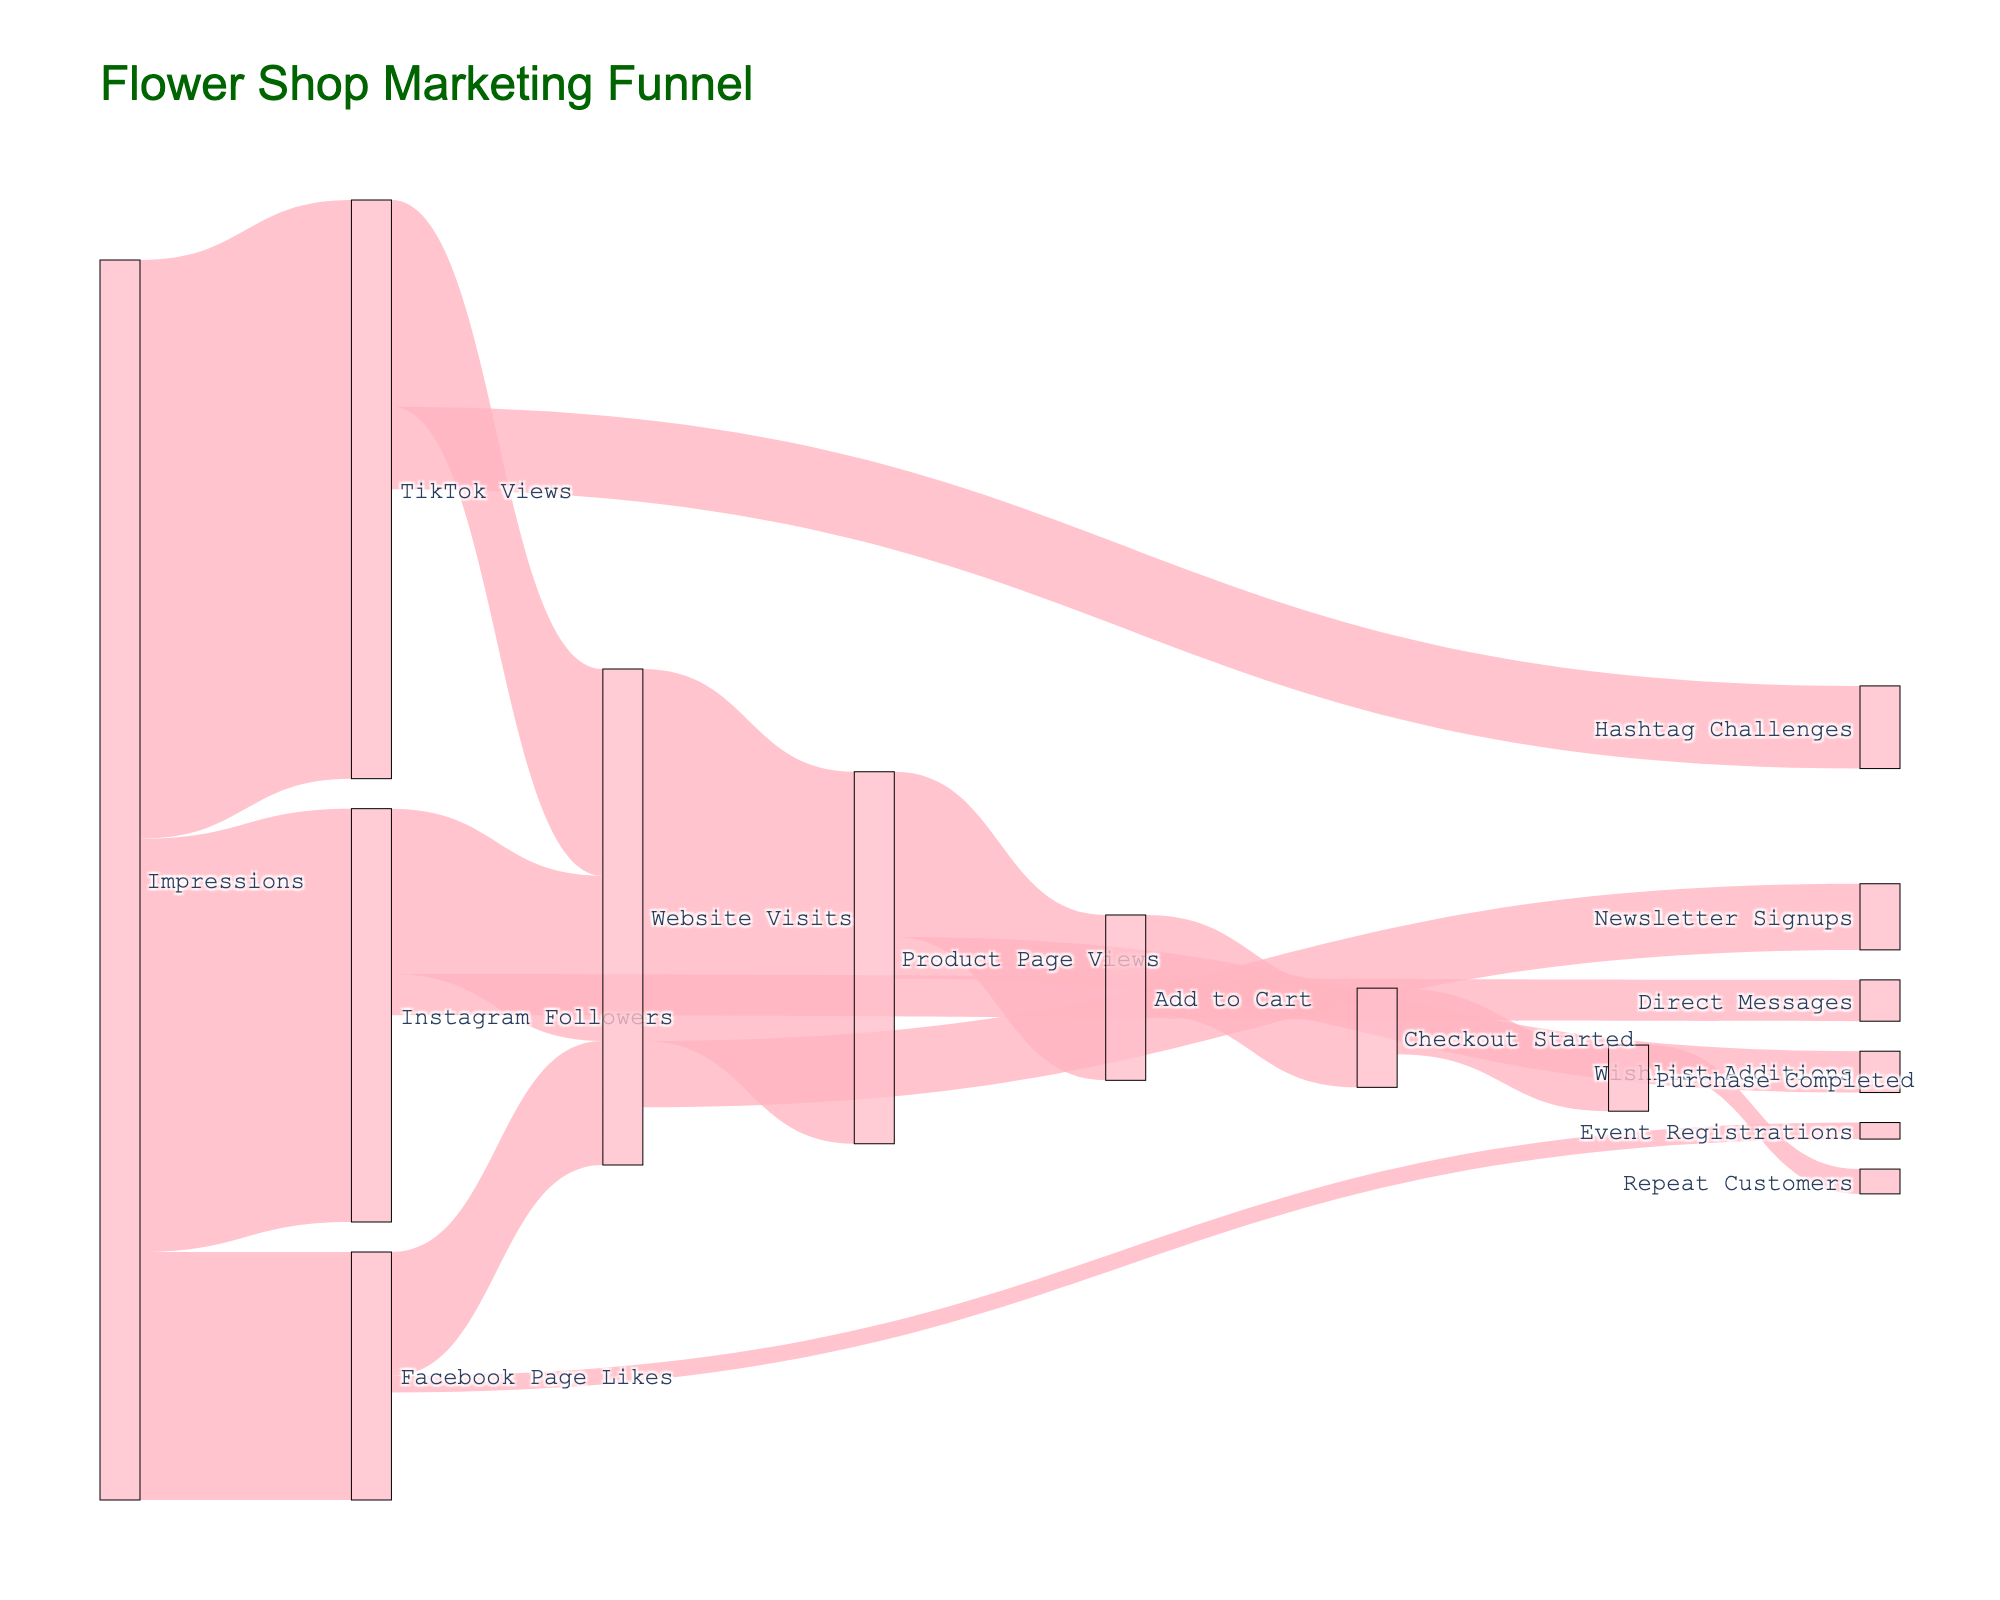What is the title of the Sankey Diagram? The title is displayed near the top center of the diagram. It reads "Flower Shop Marketing Funnel" in a dark green font.
Answer: "Flower Shop Marketing Funnel" Which social media platform has the highest number of impressions? By looking at the diagram, observe the nodes connected to "Impressions." The values are 5000 (Instagram), 3000 (Facebook), and 7000 (TikTok). Compare these values to find the highest.
Answer: TikTok How many people moved from "Add to Cart" to "Checkout Started"? Trace the flow from "Add to Cart" to "Checkout Started" in the diagram. The value of this link is given as 1200.
Answer: 1200 What is the total number of "Website Visits"? Identify the sources flowing into "Website Visits." The values are 2000 (Instagram), 1500 (Facebook), and 2500 (TikTok). Calculate the sum: 2000 + 1500 + 2500 = 6000.
Answer: 6000 Between "Product Page Views" and "Purchase Completed," which stage has a higher value? Look at the values associated with the nodes "Product Page Views" (4500) and "Purchase Completed" (800). Compare these values directly.
Answer: Product Page Views What percentage of "Checkout Started" conversions resulted in "Purchase Completed"? From "Checkout Started" to "Purchase Completed," the path value is 800 out of 1200. Calculate the percentage: (800/1200) * 100 = 66.67%.
Answer: 66.67% How many more "TikTok Views" resulted in "Website Visits" compared to "Instagram Followers"? Compare the paths from "TikTok Views" to "Website Visits" (2500) and from "Instagram Followers" to "Website Visits" (2000). Subtract: 2500 - 2000 = 500.
Answer: 500 Identify the flow with the smallest value and state its value. Examine all the flows and find the smallest value in the diagram. The path from "Facebook Page Likes" to "Event Registrations" has a value of 200.
Answer: Event Registrations (200) How many customers eventually became "Repeat Customers" after completing a purchase? Follow the flow from "Purchase Completed" to "Repeat Customers." The value for this connection is shown as 300.
Answer: 300 